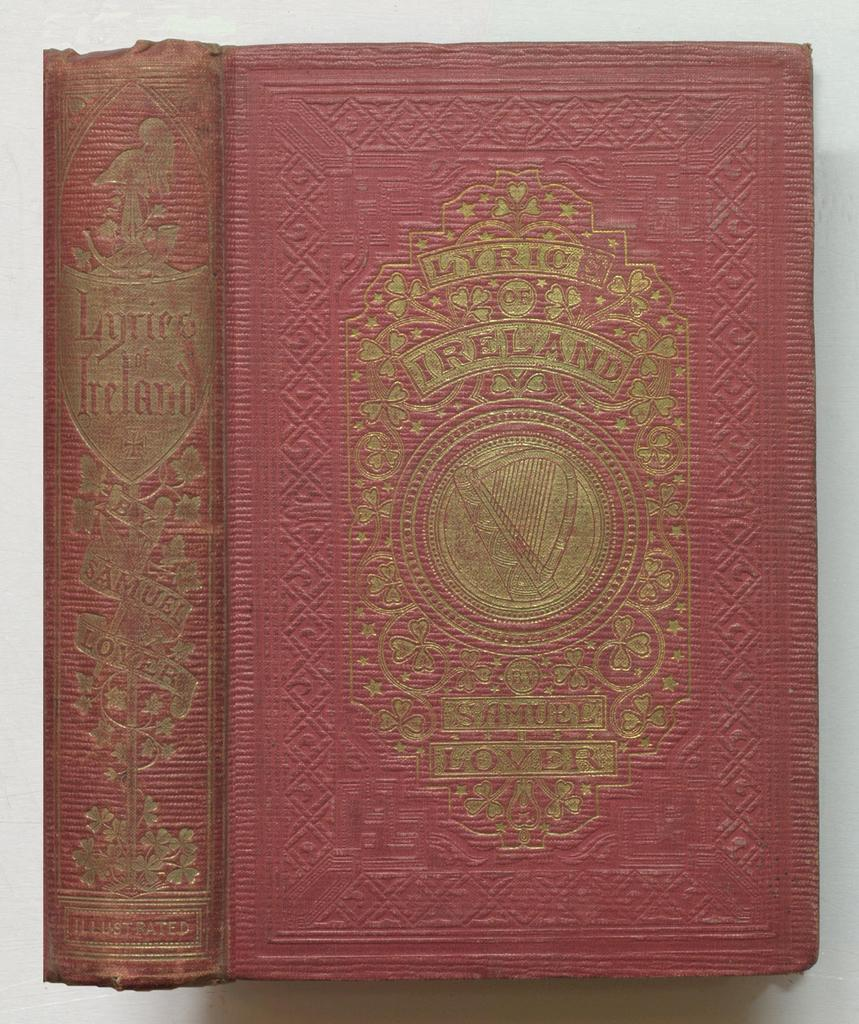Provide a one-sentence caption for the provided image. The front cover and spine of the book Lyric Of Ireland. 